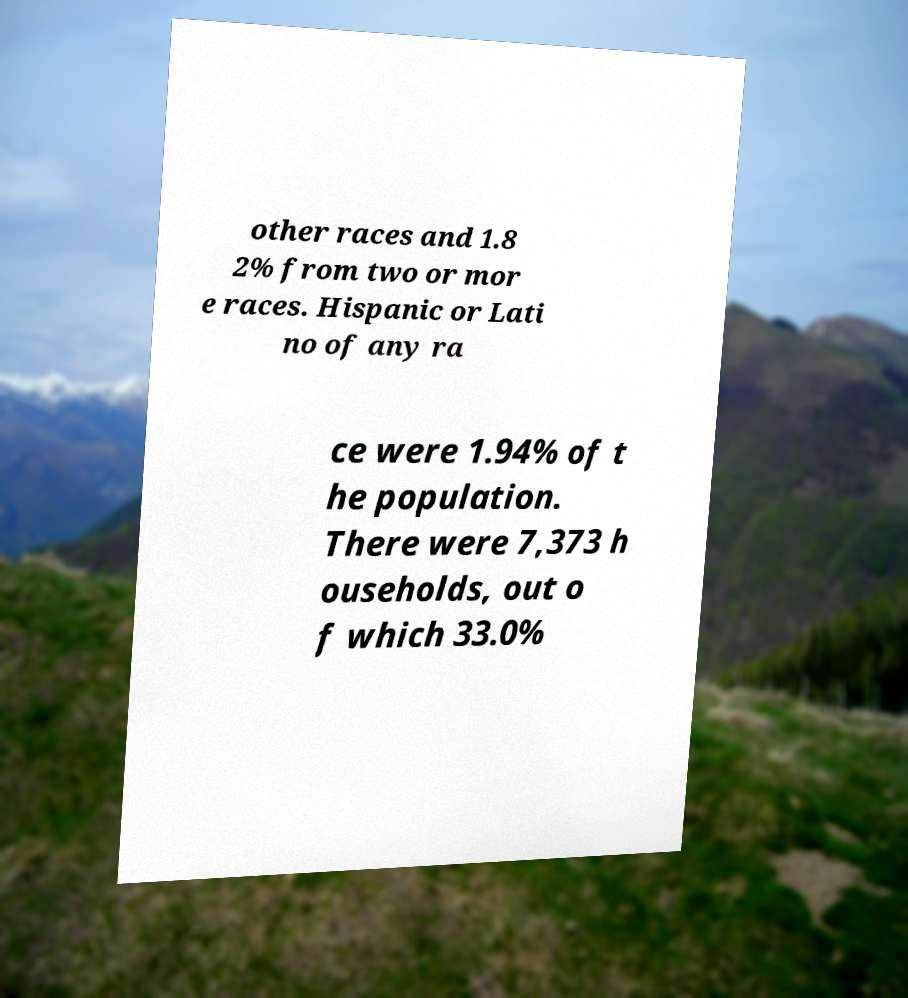Could you assist in decoding the text presented in this image and type it out clearly? other races and 1.8 2% from two or mor e races. Hispanic or Lati no of any ra ce were 1.94% of t he population. There were 7,373 h ouseholds, out o f which 33.0% 